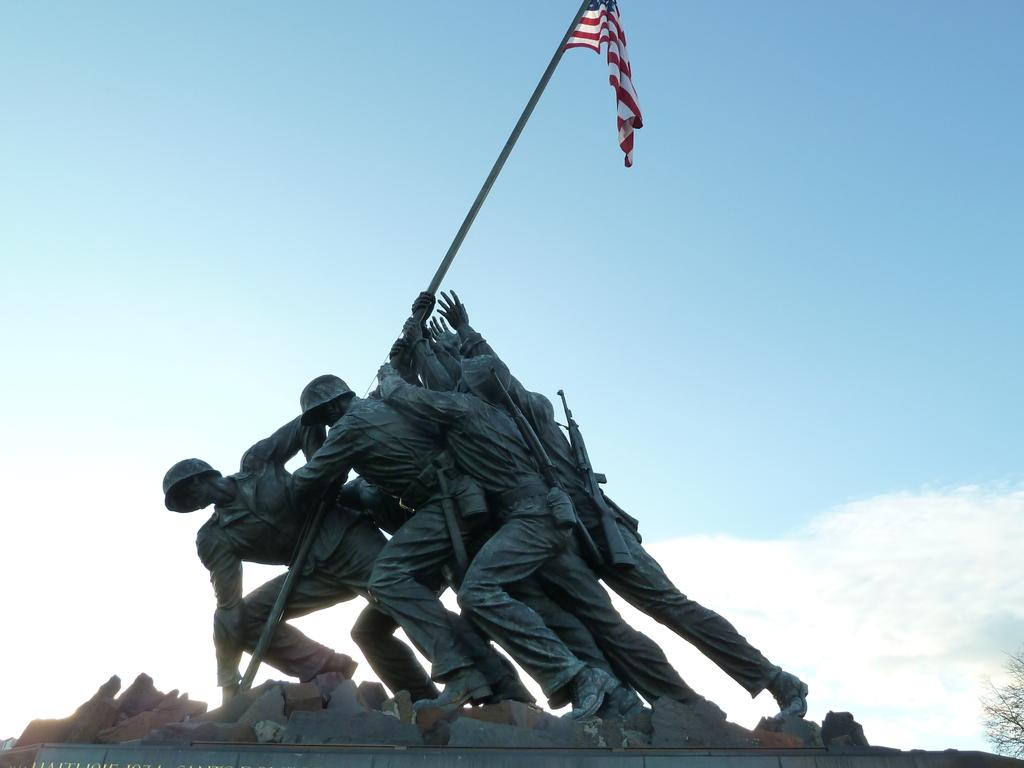How many people are in the image? There are multiple persons in the image. What are the persons holding in the image? The persons are holding a flag. What can be seen in the background of the image? There is sky visible in the background of the image. What type of police thing can be seen in the image? There is no police or thing related to police present in the image. 